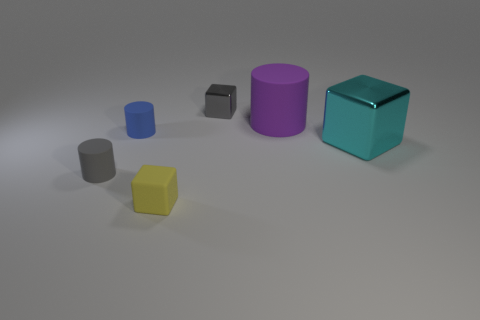Is the number of cylinders less than the number of small green matte spheres?
Ensure brevity in your answer.  No. Are there more tiny rubber cubes than small gray objects?
Provide a succinct answer. No. How many other things are there of the same material as the big block?
Keep it short and to the point. 1. What number of yellow things are behind the small block that is behind the small matte thing behind the large cyan object?
Keep it short and to the point. 0. What number of metal things are either tiny yellow objects or big things?
Your response must be concise. 1. There is a block to the left of the small cube that is behind the matte cube; how big is it?
Offer a terse response. Small. There is a tiny block that is behind the large cylinder; is its color the same as the matte object right of the yellow cube?
Your response must be concise. No. There is a object that is to the left of the small gray block and behind the gray matte object; what color is it?
Give a very brief answer. Blue. Is the cyan cube made of the same material as the tiny blue cylinder?
Keep it short and to the point. No. How many big things are gray matte cylinders or gray spheres?
Provide a short and direct response. 0. 